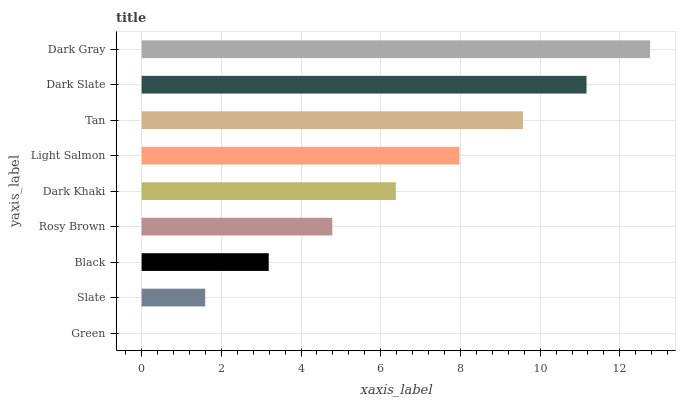Is Green the minimum?
Answer yes or no. Yes. Is Dark Gray the maximum?
Answer yes or no. Yes. Is Slate the minimum?
Answer yes or no. No. Is Slate the maximum?
Answer yes or no. No. Is Slate greater than Green?
Answer yes or no. Yes. Is Green less than Slate?
Answer yes or no. Yes. Is Green greater than Slate?
Answer yes or no. No. Is Slate less than Green?
Answer yes or no. No. Is Dark Khaki the high median?
Answer yes or no. Yes. Is Dark Khaki the low median?
Answer yes or no. Yes. Is Dark Slate the high median?
Answer yes or no. No. Is Green the low median?
Answer yes or no. No. 